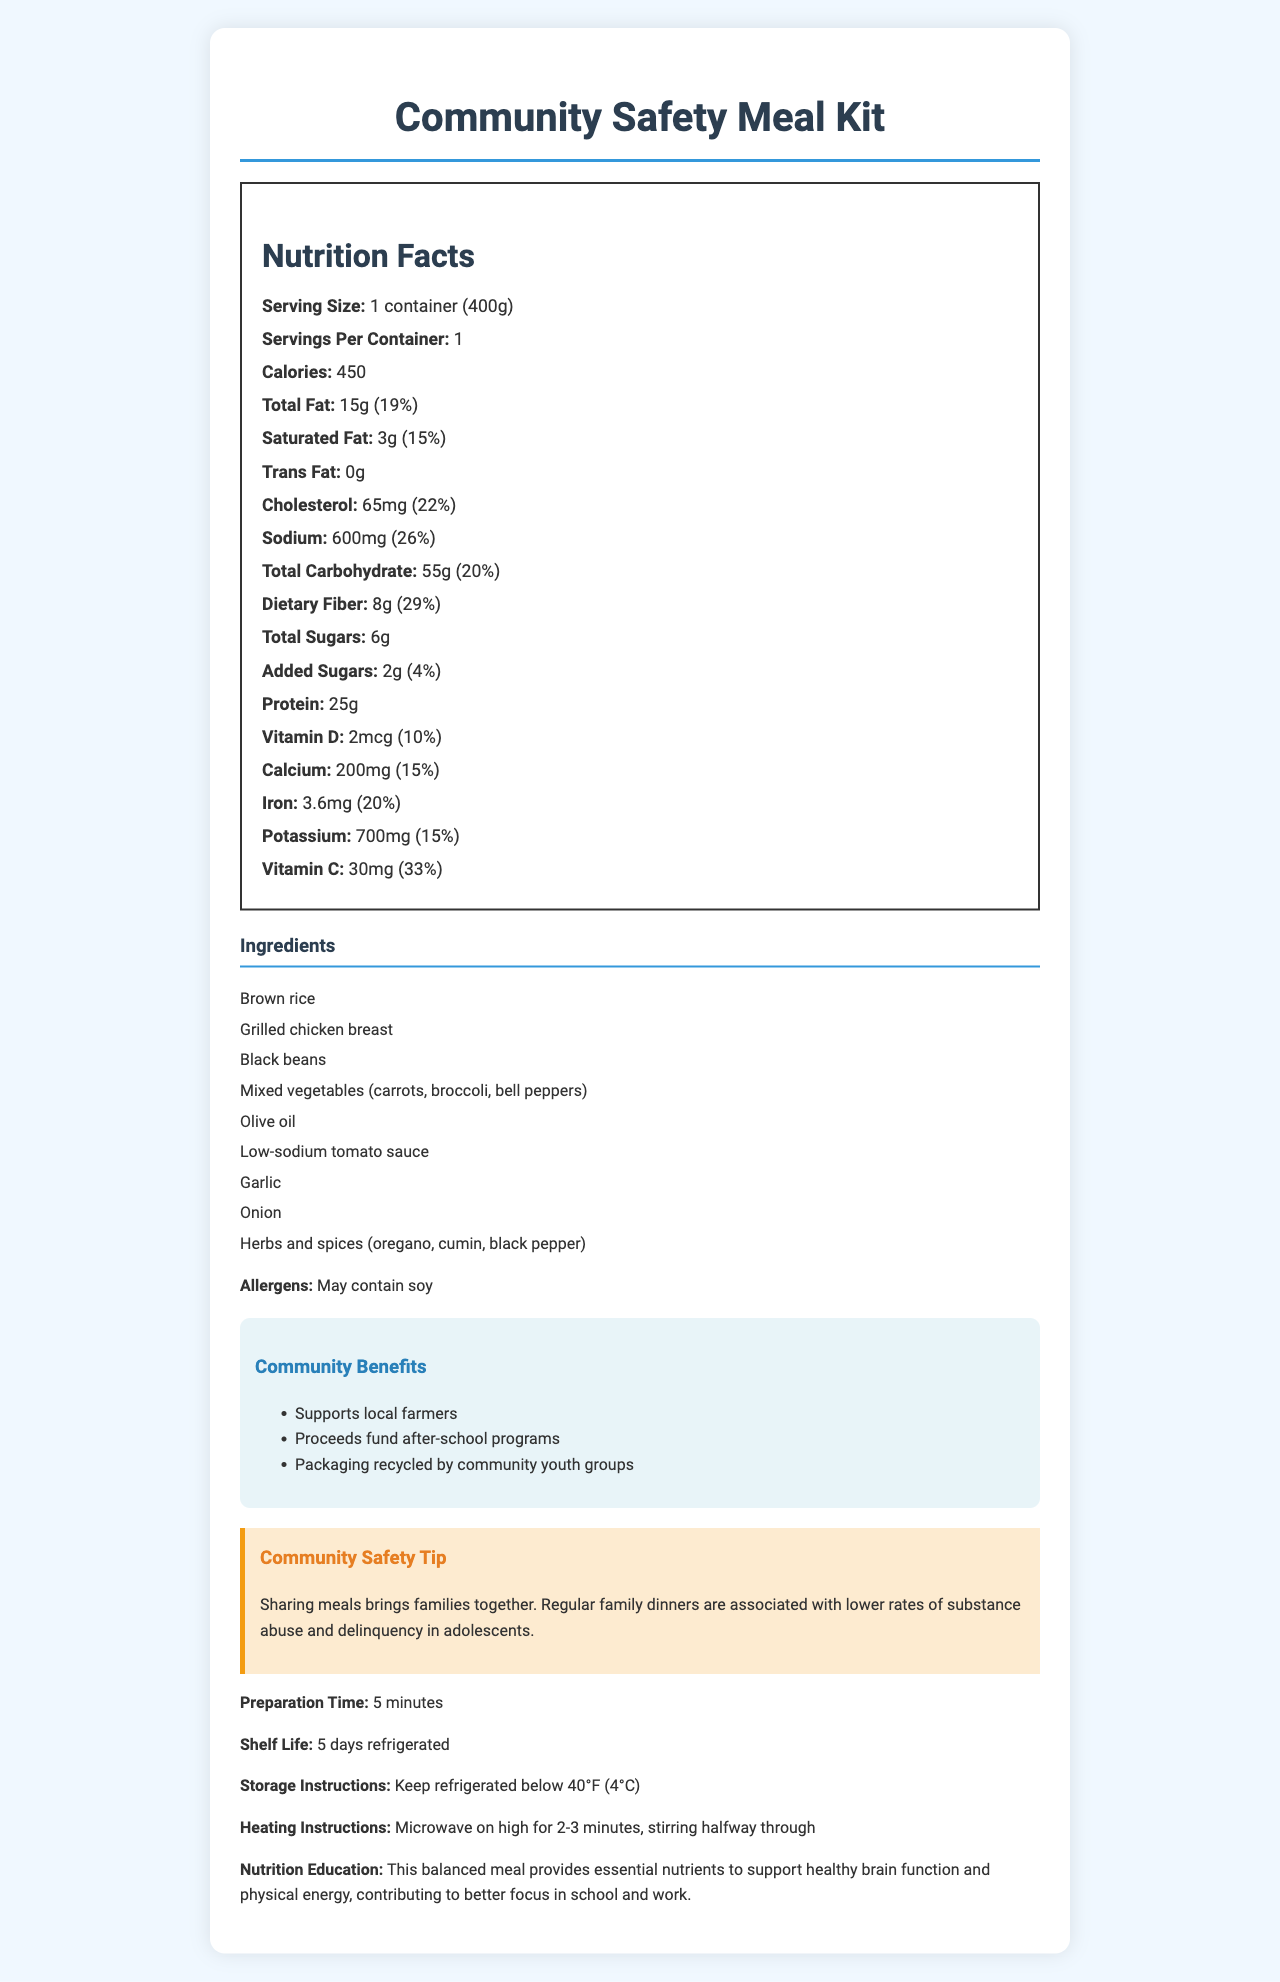what is the serving size of the Community Safety Meal Kit? The serving size is directly listed in the Nutrition Facts section as "1 container (400g)".
Answer: 1 container (400g) how many calories are in one serving? The Nutrition Facts section states that there are 450 calories per serving.
Answer: 450 how much dietary fiber does the meal kit contain, and what is its daily value percentage? The document lists dietary fiber as 8g, which accounts for 29% of the daily value.
Answer: 8g, 29% what is the sodium content of the meal kit? The sodium content is shown as 600mg in the Nutrition Facts section.
Answer: 600mg how much vitamin C does the meal kit provide in one serving, and what is its daily value percentage? The Nutrition Facts section indicates the meal kit provides 30mg of Vitamin C, which is 33% of the daily value.
Answer: 30mg, 33% which ingredient in the meal kit is the primary source of protein? A. Brown rice B. Grilled chicken breast C. Black beans D. Mixed vegetables Grilled chicken breast is typically a high-protein ingredient.
Answer: B what is the heating instruction duration for the meal kit? A. 1-2 minutes B. 2-3 minutes C. 3-4 minutes The heating instructions state to microwave on high for 2-3 minutes.
Answer: B does the meal kit contain any allergens? The document mentions that the meal kit may contain soy.
Answer: Yes are there any community benefits associated with purchasing this meal kit? The community benefits section notes that proceeds fund after-school programs, the meal kit supports local farmers, and the packaging is recycled by community youth groups.
Answer: Yes summarize the main idea of the document. This summary encapsulates the nutritious and community-focused aspects of the meal kit, its ingredient list, and the overall benefits highlighted in the document.
Answer: The Community Safety Meal Kit is designed for low-income families in high-crime areas, providing a nutritious meal with benefits like supporting local farmers, funding after-school programs, and promoting community safety. The meal kit includes ingredients such as brown rice, grilled chicken, and mixed vegetables, emphasizing low sodium and nutritional value, with easy preparation and storage instructions. what is the exact percentage of daily value for calories? The document gives calorie information but does not specify the daily value percentage for calories.
Answer: Not provided 